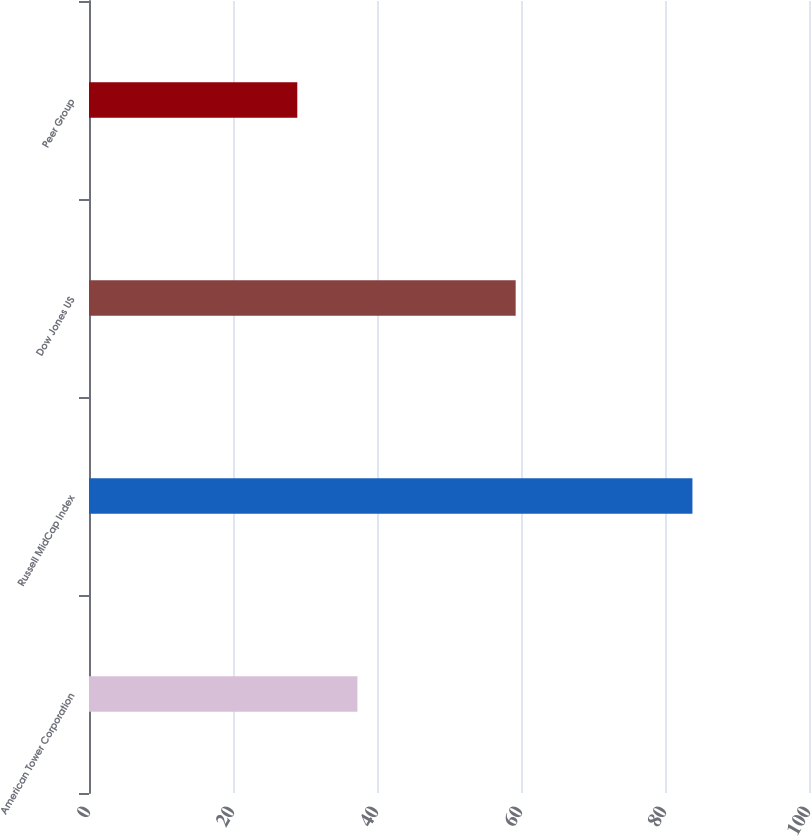<chart> <loc_0><loc_0><loc_500><loc_500><bar_chart><fcel>American Tower Corporation<fcel>Russell MidCap Index<fcel>Dow Jones US<fcel>Peer Group<nl><fcel>37.28<fcel>83.81<fcel>59.26<fcel>28.93<nl></chart> 